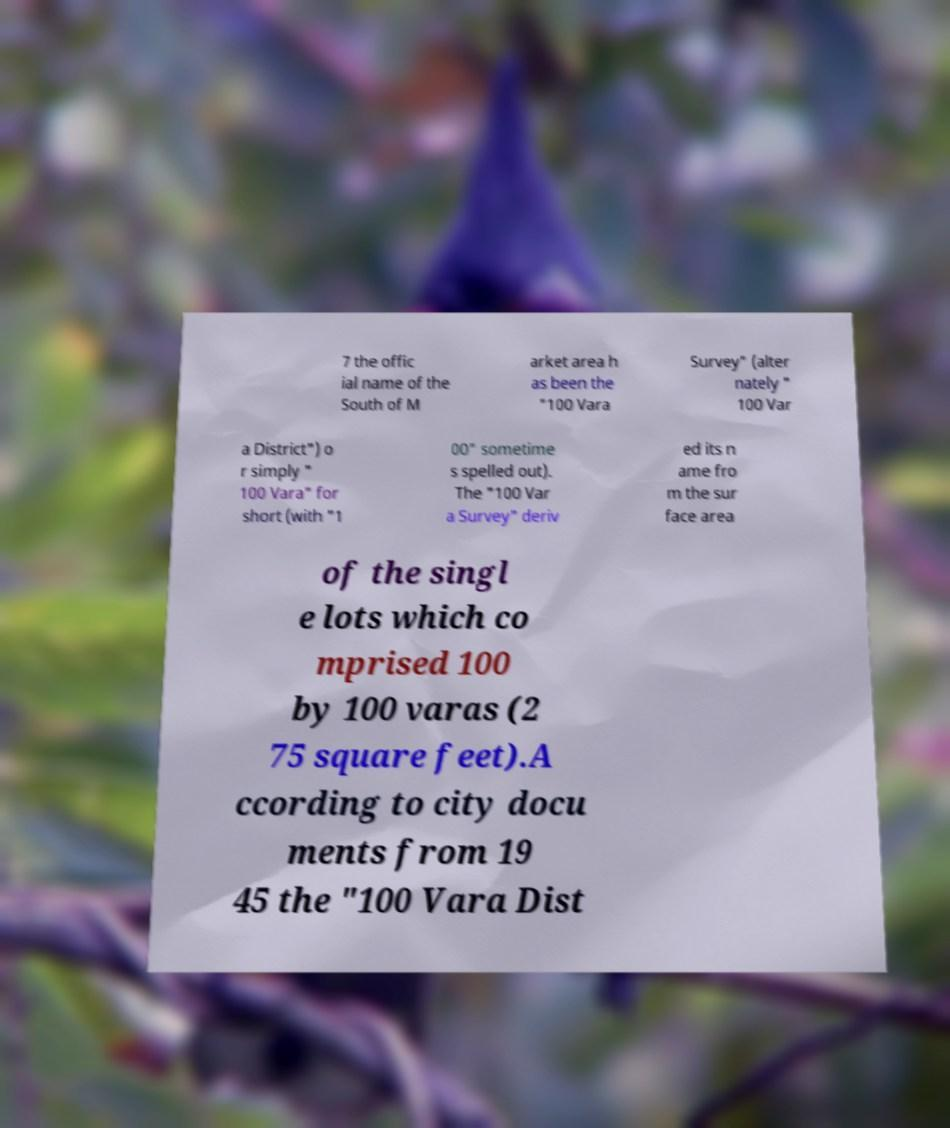Please read and relay the text visible in this image. What does it say? 7 the offic ial name of the South of M arket area h as been the "100 Vara Survey" (alter nately " 100 Var a District") o r simply " 100 Vara" for short (with "1 00" sometime s spelled out). The "100 Var a Survey" deriv ed its n ame fro m the sur face area of the singl e lots which co mprised 100 by 100 varas (2 75 square feet).A ccording to city docu ments from 19 45 the "100 Vara Dist 